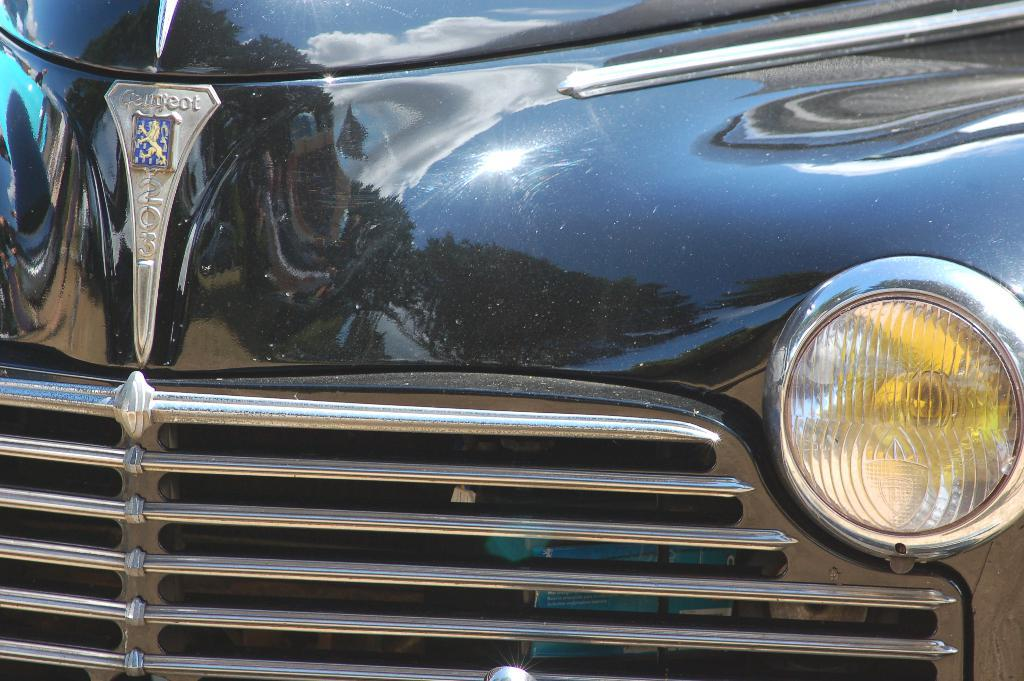What type of automotive part can be seen in the image? There is a bumper in the image. What other automotive part is visible in the image? There is a headlight in the image. What type of chain is used to secure the bumper in the image? There is no chain present in the image; it only shows a bumper and a headlight. 